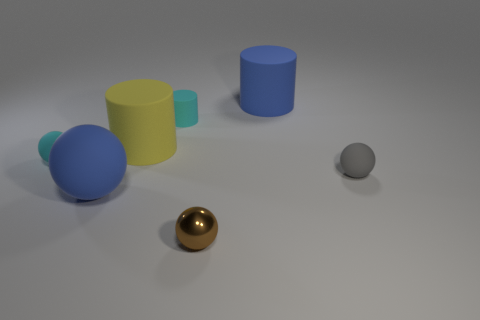Subtract all cyan spheres. How many spheres are left? 3 Add 3 small brown metal objects. How many objects exist? 10 Subtract all yellow balls. Subtract all red cylinders. How many balls are left? 4 Subtract all balls. How many objects are left? 3 Add 1 brown blocks. How many brown blocks exist? 1 Subtract 0 red balls. How many objects are left? 7 Subtract all small cyan things. Subtract all brown metallic balls. How many objects are left? 4 Add 1 rubber things. How many rubber things are left? 7 